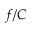<formula> <loc_0><loc_0><loc_500><loc_500>f / C</formula> 